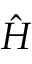Convert formula to latex. <formula><loc_0><loc_0><loc_500><loc_500>\hat { H }</formula> 